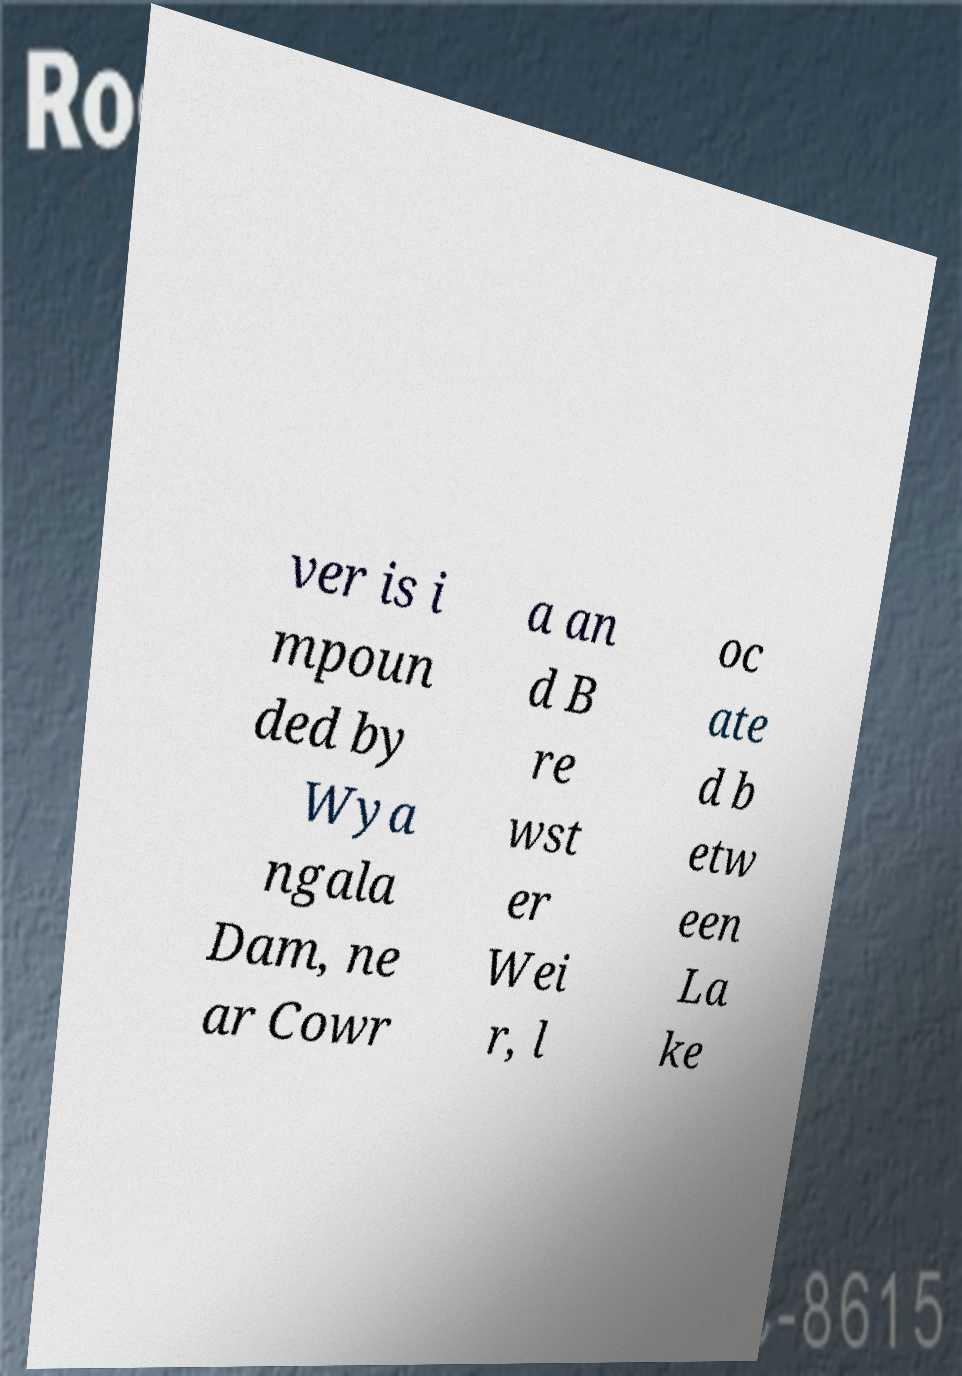Can you accurately transcribe the text from the provided image for me? ver is i mpoun ded by Wya ngala Dam, ne ar Cowr a an d B re wst er Wei r, l oc ate d b etw een La ke 